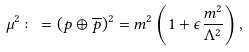Convert formula to latex. <formula><loc_0><loc_0><loc_500><loc_500>\mu ^ { 2 } \colon = ( p \oplus \overline { p } ) ^ { 2 } = m ^ { 2 } \left ( 1 + \epsilon \frac { m ^ { 2 } } { \Lambda ^ { 2 } } \right ) ,</formula> 